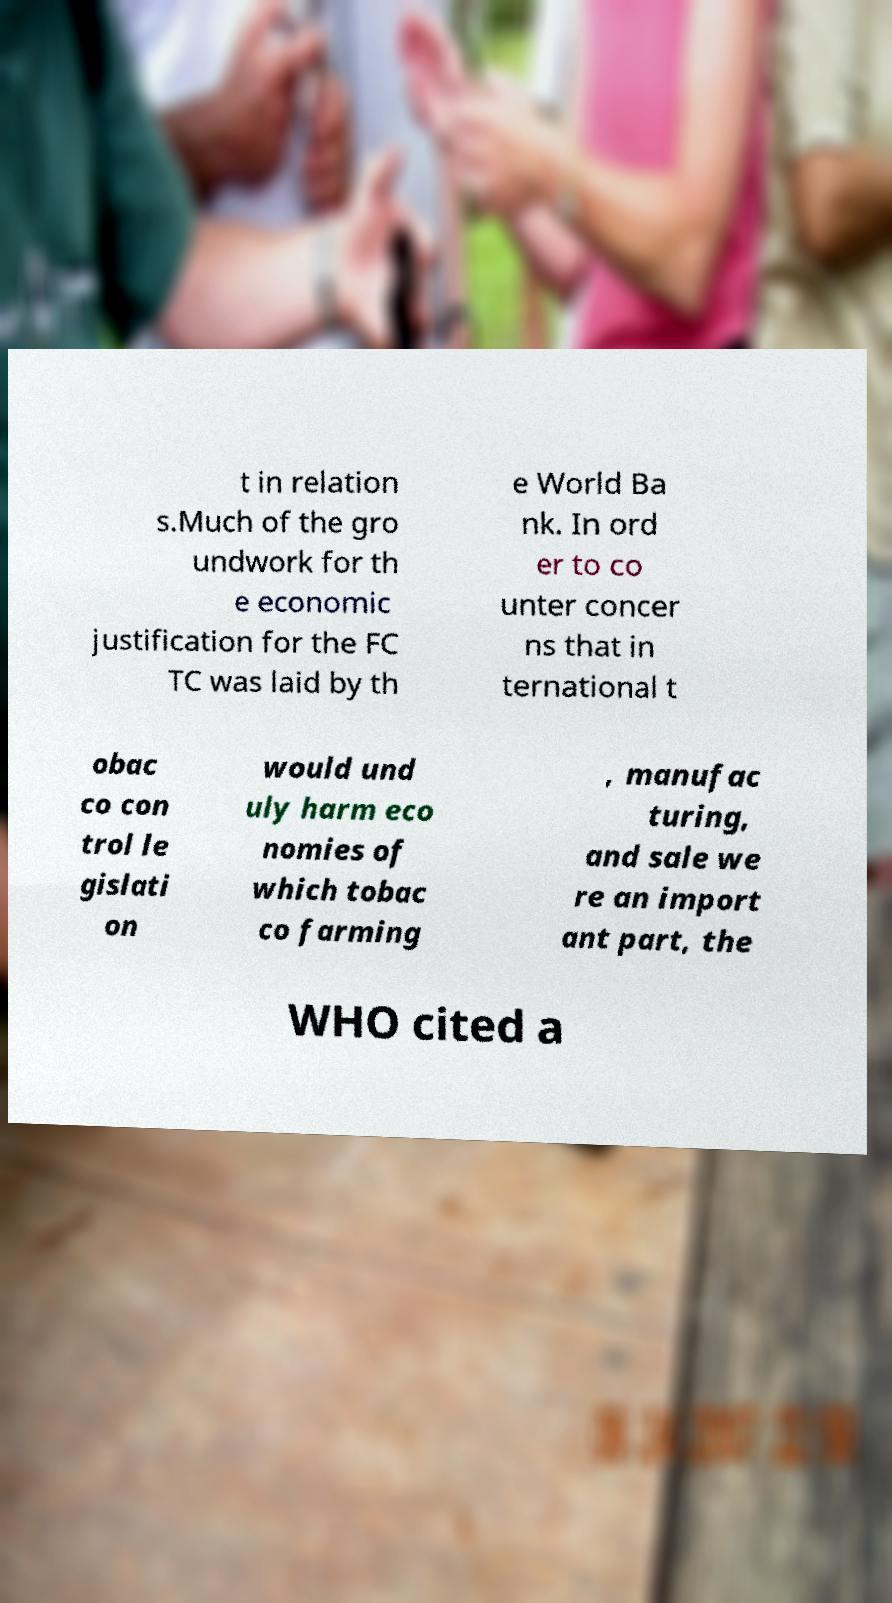There's text embedded in this image that I need extracted. Can you transcribe it verbatim? t in relation s.Much of the gro undwork for th e economic justification for the FC TC was laid by th e World Ba nk. In ord er to co unter concer ns that in ternational t obac co con trol le gislati on would und uly harm eco nomies of which tobac co farming , manufac turing, and sale we re an import ant part, the WHO cited a 